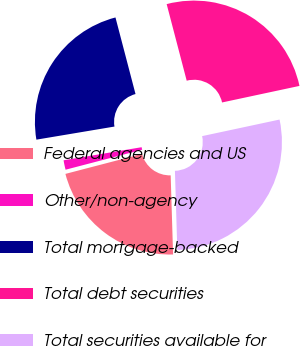<chart> <loc_0><loc_0><loc_500><loc_500><pie_chart><fcel>Federal agencies and US<fcel>Other/non-agency<fcel>Total mortgage-backed<fcel>Total debt securities<fcel>Total securities available for<nl><fcel>21.42%<fcel>1.42%<fcel>23.57%<fcel>25.72%<fcel>27.87%<nl></chart> 